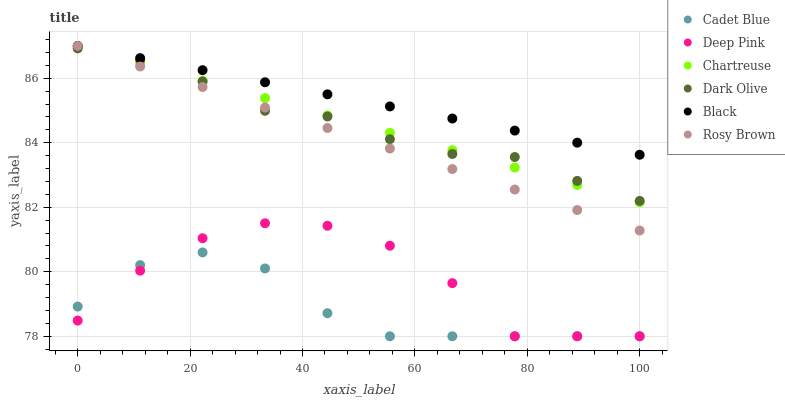Does Cadet Blue have the minimum area under the curve?
Answer yes or no. Yes. Does Black have the maximum area under the curve?
Answer yes or no. Yes. Does Dark Olive have the minimum area under the curve?
Answer yes or no. No. Does Dark Olive have the maximum area under the curve?
Answer yes or no. No. Is Black the smoothest?
Answer yes or no. Yes. Is Deep Pink the roughest?
Answer yes or no. Yes. Is Dark Olive the smoothest?
Answer yes or no. No. Is Dark Olive the roughest?
Answer yes or no. No. Does Cadet Blue have the lowest value?
Answer yes or no. Yes. Does Dark Olive have the lowest value?
Answer yes or no. No. Does Rosy Brown have the highest value?
Answer yes or no. Yes. Does Dark Olive have the highest value?
Answer yes or no. No. Is Cadet Blue less than Rosy Brown?
Answer yes or no. Yes. Is Black greater than Deep Pink?
Answer yes or no. Yes. Does Dark Olive intersect Rosy Brown?
Answer yes or no. Yes. Is Dark Olive less than Rosy Brown?
Answer yes or no. No. Is Dark Olive greater than Rosy Brown?
Answer yes or no. No. Does Cadet Blue intersect Rosy Brown?
Answer yes or no. No. 